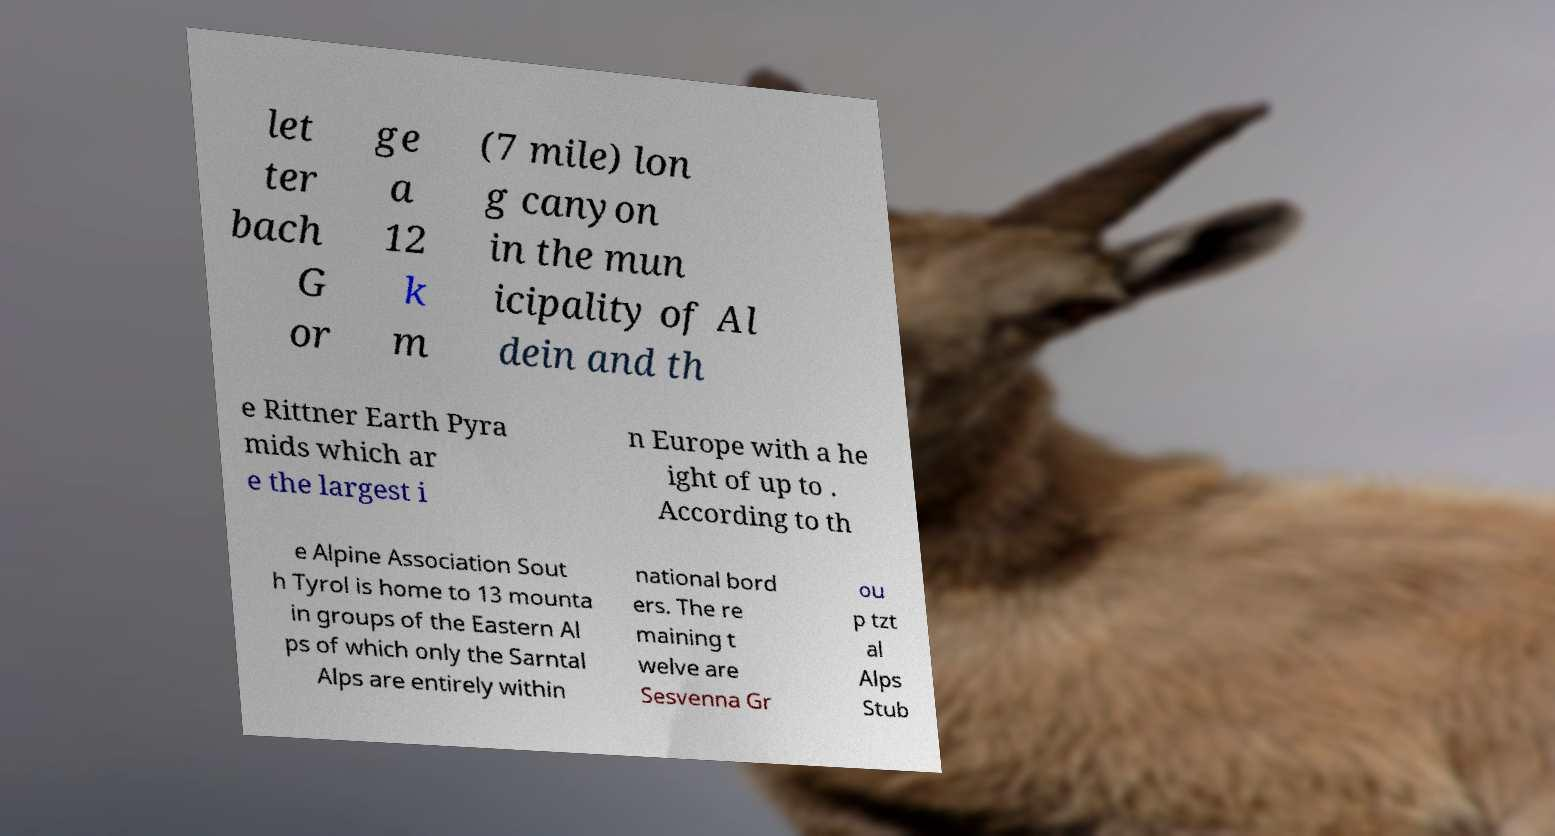Could you extract and type out the text from this image? let ter bach G or ge a 12 k m (7 mile) lon g canyon in the mun icipality of Al dein and th e Rittner Earth Pyra mids which ar e the largest i n Europe with a he ight of up to . According to th e Alpine Association Sout h Tyrol is home to 13 mounta in groups of the Eastern Al ps of which only the Sarntal Alps are entirely within national bord ers. The re maining t welve are Sesvenna Gr ou p tzt al Alps Stub 